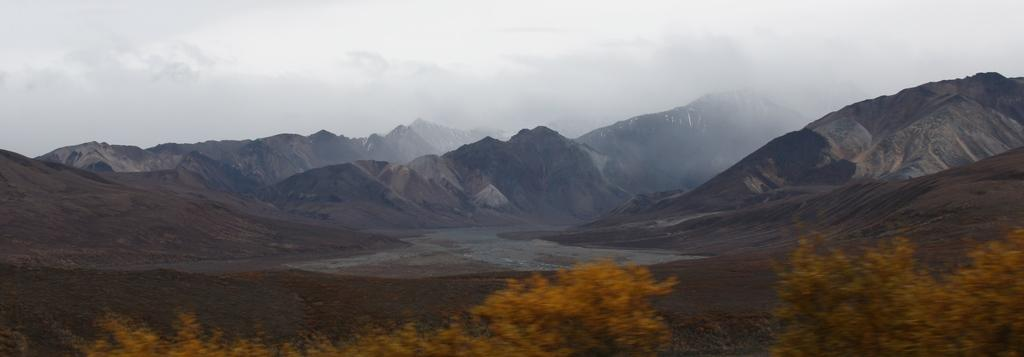What type of natural landform can be seen in the image? There are mountains in the image. What body of water is present between the mountains? There is a river passing between the mountains. How would you describe the sky in the image? The sky is cloudy in the image. What type of vegetation can be seen in the image? There are trees visible in the image. Where is the most valuable jewel hidden in the image? There is no mention of a jewel in the image, so it cannot be determined where it might be hidden. 